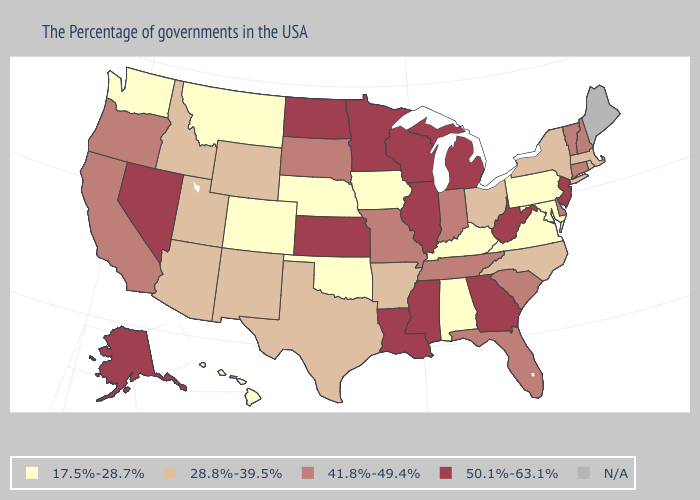Among the states that border New Jersey , does Pennsylvania have the lowest value?
Give a very brief answer. Yes. Among the states that border New York , does Pennsylvania have the highest value?
Answer briefly. No. What is the value of Oklahoma?
Concise answer only. 17.5%-28.7%. Does the first symbol in the legend represent the smallest category?
Keep it brief. Yes. What is the value of Texas?
Write a very short answer. 28.8%-39.5%. Name the states that have a value in the range 28.8%-39.5%?
Be succinct. Massachusetts, Rhode Island, New York, North Carolina, Ohio, Arkansas, Texas, Wyoming, New Mexico, Utah, Arizona, Idaho. Does Indiana have the lowest value in the USA?
Short answer required. No. Among the states that border Kansas , which have the highest value?
Give a very brief answer. Missouri. Name the states that have a value in the range 17.5%-28.7%?
Answer briefly. Maryland, Pennsylvania, Virginia, Kentucky, Alabama, Iowa, Nebraska, Oklahoma, Colorado, Montana, Washington, Hawaii. What is the value of New Hampshire?
Be succinct. 41.8%-49.4%. What is the value of Louisiana?
Quick response, please. 50.1%-63.1%. Name the states that have a value in the range 28.8%-39.5%?
Quick response, please. Massachusetts, Rhode Island, New York, North Carolina, Ohio, Arkansas, Texas, Wyoming, New Mexico, Utah, Arizona, Idaho. Name the states that have a value in the range 50.1%-63.1%?
Write a very short answer. New Jersey, West Virginia, Georgia, Michigan, Wisconsin, Illinois, Mississippi, Louisiana, Minnesota, Kansas, North Dakota, Nevada, Alaska. 